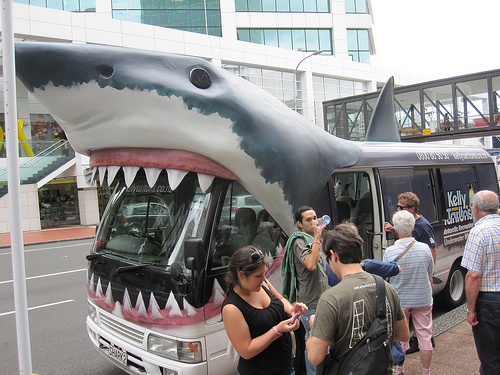<image>
Is the bus in the shark? Yes. The bus is contained within or inside the shark, showing a containment relationship. Is there a old woman in front of the shark bus? Yes. The old woman is positioned in front of the shark bus, appearing closer to the camera viewpoint. 